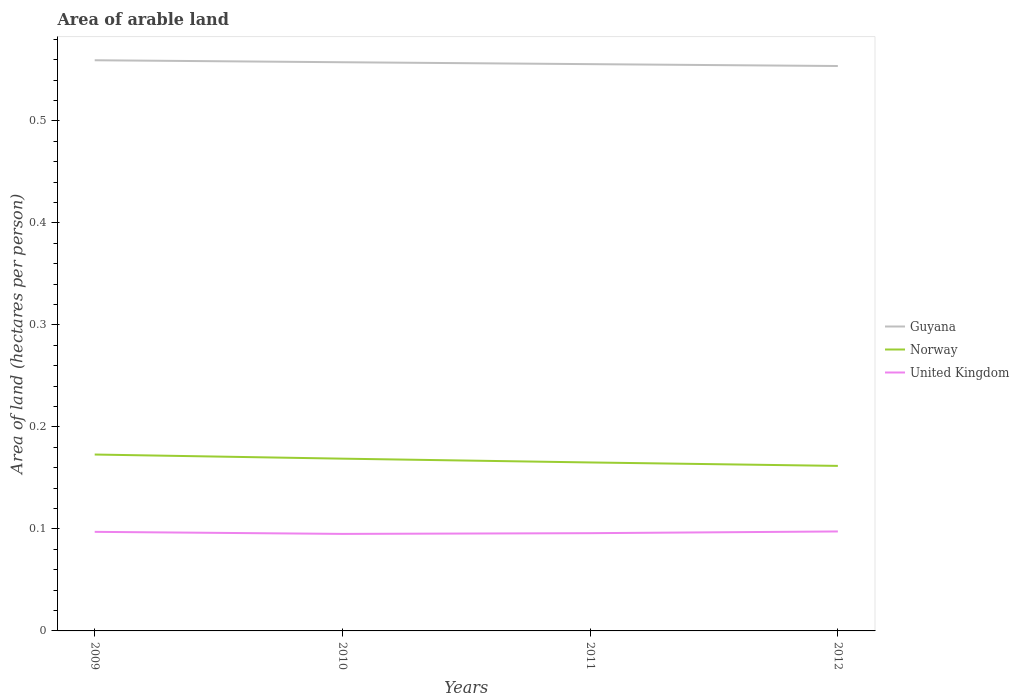How many different coloured lines are there?
Ensure brevity in your answer.  3. Is the number of lines equal to the number of legend labels?
Ensure brevity in your answer.  Yes. Across all years, what is the maximum total arable land in Norway?
Provide a succinct answer. 0.16. What is the total total arable land in Norway in the graph?
Offer a very short reply. 0.01. What is the difference between the highest and the second highest total arable land in Norway?
Your answer should be compact. 0.01. What is the difference between the highest and the lowest total arable land in Guyana?
Provide a succinct answer. 2. How many lines are there?
Keep it short and to the point. 3. Are the values on the major ticks of Y-axis written in scientific E-notation?
Offer a very short reply. No. Does the graph contain any zero values?
Offer a very short reply. No. How many legend labels are there?
Your answer should be compact. 3. What is the title of the graph?
Give a very brief answer. Area of arable land. What is the label or title of the Y-axis?
Your response must be concise. Area of land (hectares per person). What is the Area of land (hectares per person) of Guyana in 2009?
Give a very brief answer. 0.56. What is the Area of land (hectares per person) in Norway in 2009?
Ensure brevity in your answer.  0.17. What is the Area of land (hectares per person) of United Kingdom in 2009?
Make the answer very short. 0.1. What is the Area of land (hectares per person) of Guyana in 2010?
Provide a short and direct response. 0.56. What is the Area of land (hectares per person) of Norway in 2010?
Offer a terse response. 0.17. What is the Area of land (hectares per person) of United Kingdom in 2010?
Ensure brevity in your answer.  0.1. What is the Area of land (hectares per person) of Guyana in 2011?
Provide a short and direct response. 0.56. What is the Area of land (hectares per person) of Norway in 2011?
Provide a short and direct response. 0.17. What is the Area of land (hectares per person) of United Kingdom in 2011?
Provide a short and direct response. 0.1. What is the Area of land (hectares per person) in Guyana in 2012?
Give a very brief answer. 0.55. What is the Area of land (hectares per person) in Norway in 2012?
Your answer should be compact. 0.16. What is the Area of land (hectares per person) in United Kingdom in 2012?
Your answer should be very brief. 0.1. Across all years, what is the maximum Area of land (hectares per person) in Guyana?
Provide a succinct answer. 0.56. Across all years, what is the maximum Area of land (hectares per person) in Norway?
Your answer should be very brief. 0.17. Across all years, what is the maximum Area of land (hectares per person) in United Kingdom?
Offer a very short reply. 0.1. Across all years, what is the minimum Area of land (hectares per person) in Guyana?
Your answer should be very brief. 0.55. Across all years, what is the minimum Area of land (hectares per person) in Norway?
Keep it short and to the point. 0.16. Across all years, what is the minimum Area of land (hectares per person) in United Kingdom?
Make the answer very short. 0.1. What is the total Area of land (hectares per person) of Guyana in the graph?
Give a very brief answer. 2.23. What is the total Area of land (hectares per person) in Norway in the graph?
Offer a very short reply. 0.67. What is the total Area of land (hectares per person) in United Kingdom in the graph?
Your answer should be very brief. 0.39. What is the difference between the Area of land (hectares per person) of Guyana in 2009 and that in 2010?
Make the answer very short. 0. What is the difference between the Area of land (hectares per person) of Norway in 2009 and that in 2010?
Provide a succinct answer. 0. What is the difference between the Area of land (hectares per person) in United Kingdom in 2009 and that in 2010?
Your response must be concise. 0. What is the difference between the Area of land (hectares per person) of Guyana in 2009 and that in 2011?
Make the answer very short. 0. What is the difference between the Area of land (hectares per person) in Norway in 2009 and that in 2011?
Your answer should be compact. 0.01. What is the difference between the Area of land (hectares per person) of United Kingdom in 2009 and that in 2011?
Offer a terse response. 0. What is the difference between the Area of land (hectares per person) of Guyana in 2009 and that in 2012?
Your answer should be compact. 0.01. What is the difference between the Area of land (hectares per person) in Norway in 2009 and that in 2012?
Give a very brief answer. 0.01. What is the difference between the Area of land (hectares per person) in United Kingdom in 2009 and that in 2012?
Provide a short and direct response. -0. What is the difference between the Area of land (hectares per person) in Guyana in 2010 and that in 2011?
Your answer should be compact. 0. What is the difference between the Area of land (hectares per person) of Norway in 2010 and that in 2011?
Offer a very short reply. 0. What is the difference between the Area of land (hectares per person) of United Kingdom in 2010 and that in 2011?
Provide a succinct answer. -0. What is the difference between the Area of land (hectares per person) in Guyana in 2010 and that in 2012?
Your answer should be compact. 0. What is the difference between the Area of land (hectares per person) of Norway in 2010 and that in 2012?
Provide a succinct answer. 0.01. What is the difference between the Area of land (hectares per person) in United Kingdom in 2010 and that in 2012?
Your answer should be compact. -0. What is the difference between the Area of land (hectares per person) of Guyana in 2011 and that in 2012?
Provide a succinct answer. 0. What is the difference between the Area of land (hectares per person) of Norway in 2011 and that in 2012?
Your answer should be very brief. 0. What is the difference between the Area of land (hectares per person) of United Kingdom in 2011 and that in 2012?
Your response must be concise. -0. What is the difference between the Area of land (hectares per person) in Guyana in 2009 and the Area of land (hectares per person) in Norway in 2010?
Keep it short and to the point. 0.39. What is the difference between the Area of land (hectares per person) in Guyana in 2009 and the Area of land (hectares per person) in United Kingdom in 2010?
Ensure brevity in your answer.  0.46. What is the difference between the Area of land (hectares per person) of Norway in 2009 and the Area of land (hectares per person) of United Kingdom in 2010?
Provide a succinct answer. 0.08. What is the difference between the Area of land (hectares per person) of Guyana in 2009 and the Area of land (hectares per person) of Norway in 2011?
Ensure brevity in your answer.  0.39. What is the difference between the Area of land (hectares per person) in Guyana in 2009 and the Area of land (hectares per person) in United Kingdom in 2011?
Your response must be concise. 0.46. What is the difference between the Area of land (hectares per person) in Norway in 2009 and the Area of land (hectares per person) in United Kingdom in 2011?
Ensure brevity in your answer.  0.08. What is the difference between the Area of land (hectares per person) in Guyana in 2009 and the Area of land (hectares per person) in Norway in 2012?
Provide a short and direct response. 0.4. What is the difference between the Area of land (hectares per person) of Guyana in 2009 and the Area of land (hectares per person) of United Kingdom in 2012?
Provide a succinct answer. 0.46. What is the difference between the Area of land (hectares per person) in Norway in 2009 and the Area of land (hectares per person) in United Kingdom in 2012?
Provide a short and direct response. 0.08. What is the difference between the Area of land (hectares per person) of Guyana in 2010 and the Area of land (hectares per person) of Norway in 2011?
Give a very brief answer. 0.39. What is the difference between the Area of land (hectares per person) of Guyana in 2010 and the Area of land (hectares per person) of United Kingdom in 2011?
Keep it short and to the point. 0.46. What is the difference between the Area of land (hectares per person) of Norway in 2010 and the Area of land (hectares per person) of United Kingdom in 2011?
Your answer should be compact. 0.07. What is the difference between the Area of land (hectares per person) in Guyana in 2010 and the Area of land (hectares per person) in Norway in 2012?
Provide a short and direct response. 0.4. What is the difference between the Area of land (hectares per person) in Guyana in 2010 and the Area of land (hectares per person) in United Kingdom in 2012?
Keep it short and to the point. 0.46. What is the difference between the Area of land (hectares per person) of Norway in 2010 and the Area of land (hectares per person) of United Kingdom in 2012?
Provide a succinct answer. 0.07. What is the difference between the Area of land (hectares per person) of Guyana in 2011 and the Area of land (hectares per person) of Norway in 2012?
Provide a succinct answer. 0.39. What is the difference between the Area of land (hectares per person) in Guyana in 2011 and the Area of land (hectares per person) in United Kingdom in 2012?
Your answer should be very brief. 0.46. What is the difference between the Area of land (hectares per person) of Norway in 2011 and the Area of land (hectares per person) of United Kingdom in 2012?
Provide a short and direct response. 0.07. What is the average Area of land (hectares per person) of Guyana per year?
Ensure brevity in your answer.  0.56. What is the average Area of land (hectares per person) of Norway per year?
Your response must be concise. 0.17. What is the average Area of land (hectares per person) in United Kingdom per year?
Your answer should be very brief. 0.1. In the year 2009, what is the difference between the Area of land (hectares per person) in Guyana and Area of land (hectares per person) in Norway?
Offer a terse response. 0.39. In the year 2009, what is the difference between the Area of land (hectares per person) of Guyana and Area of land (hectares per person) of United Kingdom?
Provide a short and direct response. 0.46. In the year 2009, what is the difference between the Area of land (hectares per person) in Norway and Area of land (hectares per person) in United Kingdom?
Offer a terse response. 0.08. In the year 2010, what is the difference between the Area of land (hectares per person) of Guyana and Area of land (hectares per person) of Norway?
Your response must be concise. 0.39. In the year 2010, what is the difference between the Area of land (hectares per person) of Guyana and Area of land (hectares per person) of United Kingdom?
Your response must be concise. 0.46. In the year 2010, what is the difference between the Area of land (hectares per person) in Norway and Area of land (hectares per person) in United Kingdom?
Ensure brevity in your answer.  0.07. In the year 2011, what is the difference between the Area of land (hectares per person) of Guyana and Area of land (hectares per person) of Norway?
Keep it short and to the point. 0.39. In the year 2011, what is the difference between the Area of land (hectares per person) of Guyana and Area of land (hectares per person) of United Kingdom?
Provide a short and direct response. 0.46. In the year 2011, what is the difference between the Area of land (hectares per person) in Norway and Area of land (hectares per person) in United Kingdom?
Keep it short and to the point. 0.07. In the year 2012, what is the difference between the Area of land (hectares per person) in Guyana and Area of land (hectares per person) in Norway?
Provide a short and direct response. 0.39. In the year 2012, what is the difference between the Area of land (hectares per person) in Guyana and Area of land (hectares per person) in United Kingdom?
Your response must be concise. 0.46. In the year 2012, what is the difference between the Area of land (hectares per person) in Norway and Area of land (hectares per person) in United Kingdom?
Your answer should be compact. 0.06. What is the ratio of the Area of land (hectares per person) of Norway in 2009 to that in 2010?
Ensure brevity in your answer.  1.02. What is the ratio of the Area of land (hectares per person) in United Kingdom in 2009 to that in 2010?
Make the answer very short. 1.02. What is the ratio of the Area of land (hectares per person) of Guyana in 2009 to that in 2011?
Your answer should be very brief. 1.01. What is the ratio of the Area of land (hectares per person) of Norway in 2009 to that in 2011?
Your response must be concise. 1.05. What is the ratio of the Area of land (hectares per person) in United Kingdom in 2009 to that in 2011?
Your answer should be compact. 1.01. What is the ratio of the Area of land (hectares per person) of Guyana in 2009 to that in 2012?
Ensure brevity in your answer.  1.01. What is the ratio of the Area of land (hectares per person) of Norway in 2009 to that in 2012?
Offer a terse response. 1.07. What is the ratio of the Area of land (hectares per person) of Norway in 2010 to that in 2011?
Keep it short and to the point. 1.02. What is the ratio of the Area of land (hectares per person) in United Kingdom in 2010 to that in 2011?
Your response must be concise. 0.99. What is the ratio of the Area of land (hectares per person) of Guyana in 2010 to that in 2012?
Your response must be concise. 1.01. What is the ratio of the Area of land (hectares per person) of Norway in 2010 to that in 2012?
Offer a terse response. 1.04. What is the ratio of the Area of land (hectares per person) in United Kingdom in 2010 to that in 2012?
Offer a terse response. 0.98. What is the ratio of the Area of land (hectares per person) of Guyana in 2011 to that in 2012?
Your answer should be compact. 1. What is the ratio of the Area of land (hectares per person) in Norway in 2011 to that in 2012?
Provide a short and direct response. 1.02. What is the ratio of the Area of land (hectares per person) of United Kingdom in 2011 to that in 2012?
Your response must be concise. 0.98. What is the difference between the highest and the second highest Area of land (hectares per person) of Guyana?
Give a very brief answer. 0. What is the difference between the highest and the second highest Area of land (hectares per person) of Norway?
Keep it short and to the point. 0. What is the difference between the highest and the second highest Area of land (hectares per person) of United Kingdom?
Provide a succinct answer. 0. What is the difference between the highest and the lowest Area of land (hectares per person) of Guyana?
Make the answer very short. 0.01. What is the difference between the highest and the lowest Area of land (hectares per person) in Norway?
Your response must be concise. 0.01. What is the difference between the highest and the lowest Area of land (hectares per person) in United Kingdom?
Offer a very short reply. 0. 